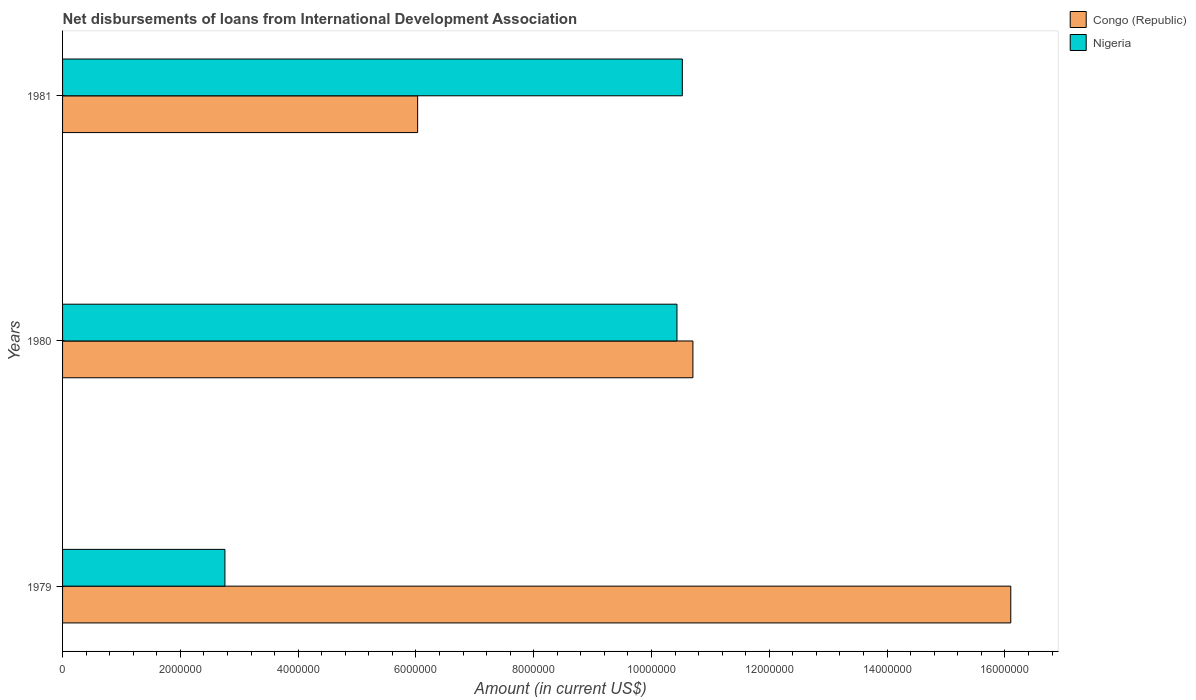How many different coloured bars are there?
Make the answer very short. 2. Are the number of bars per tick equal to the number of legend labels?
Provide a short and direct response. Yes. Are the number of bars on each tick of the Y-axis equal?
Provide a succinct answer. Yes. How many bars are there on the 1st tick from the bottom?
Offer a terse response. 2. What is the label of the 2nd group of bars from the top?
Your answer should be very brief. 1980. What is the amount of loans disbursed in Nigeria in 1981?
Your response must be concise. 1.05e+07. Across all years, what is the maximum amount of loans disbursed in Nigeria?
Make the answer very short. 1.05e+07. Across all years, what is the minimum amount of loans disbursed in Congo (Republic)?
Your response must be concise. 6.03e+06. In which year was the amount of loans disbursed in Nigeria minimum?
Offer a terse response. 1979. What is the total amount of loans disbursed in Congo (Republic) in the graph?
Give a very brief answer. 3.28e+07. What is the difference between the amount of loans disbursed in Nigeria in 1979 and that in 1981?
Provide a short and direct response. -7.77e+06. What is the difference between the amount of loans disbursed in Nigeria in 1981 and the amount of loans disbursed in Congo (Republic) in 1979?
Ensure brevity in your answer.  -5.58e+06. What is the average amount of loans disbursed in Nigeria per year?
Your answer should be compact. 7.90e+06. In the year 1980, what is the difference between the amount of loans disbursed in Nigeria and amount of loans disbursed in Congo (Republic)?
Your answer should be very brief. -2.71e+05. In how many years, is the amount of loans disbursed in Congo (Republic) greater than 10400000 US$?
Provide a succinct answer. 2. What is the ratio of the amount of loans disbursed in Nigeria in 1980 to that in 1981?
Your response must be concise. 0.99. What is the difference between the highest and the second highest amount of loans disbursed in Nigeria?
Make the answer very short. 9.10e+04. What is the difference between the highest and the lowest amount of loans disbursed in Nigeria?
Offer a very short reply. 7.77e+06. In how many years, is the amount of loans disbursed in Congo (Republic) greater than the average amount of loans disbursed in Congo (Republic) taken over all years?
Offer a very short reply. 1. Is the sum of the amount of loans disbursed in Congo (Republic) in 1980 and 1981 greater than the maximum amount of loans disbursed in Nigeria across all years?
Give a very brief answer. Yes. What does the 2nd bar from the top in 1980 represents?
Provide a short and direct response. Congo (Republic). What does the 2nd bar from the bottom in 1979 represents?
Provide a short and direct response. Nigeria. How many years are there in the graph?
Give a very brief answer. 3. Are the values on the major ticks of X-axis written in scientific E-notation?
Your response must be concise. No. Does the graph contain any zero values?
Make the answer very short. No. Does the graph contain grids?
Offer a very short reply. No. Where does the legend appear in the graph?
Offer a terse response. Top right. What is the title of the graph?
Provide a short and direct response. Net disbursements of loans from International Development Association. What is the label or title of the X-axis?
Provide a succinct answer. Amount (in current US$). What is the label or title of the Y-axis?
Provide a short and direct response. Years. What is the Amount (in current US$) in Congo (Republic) in 1979?
Offer a very short reply. 1.61e+07. What is the Amount (in current US$) of Nigeria in 1979?
Offer a very short reply. 2.76e+06. What is the Amount (in current US$) in Congo (Republic) in 1980?
Ensure brevity in your answer.  1.07e+07. What is the Amount (in current US$) in Nigeria in 1980?
Ensure brevity in your answer.  1.04e+07. What is the Amount (in current US$) of Congo (Republic) in 1981?
Provide a succinct answer. 6.03e+06. What is the Amount (in current US$) of Nigeria in 1981?
Your response must be concise. 1.05e+07. Across all years, what is the maximum Amount (in current US$) in Congo (Republic)?
Ensure brevity in your answer.  1.61e+07. Across all years, what is the maximum Amount (in current US$) of Nigeria?
Offer a terse response. 1.05e+07. Across all years, what is the minimum Amount (in current US$) in Congo (Republic)?
Offer a very short reply. 6.03e+06. Across all years, what is the minimum Amount (in current US$) of Nigeria?
Your response must be concise. 2.76e+06. What is the total Amount (in current US$) of Congo (Republic) in the graph?
Provide a short and direct response. 3.28e+07. What is the total Amount (in current US$) of Nigeria in the graph?
Your answer should be very brief. 2.37e+07. What is the difference between the Amount (in current US$) of Congo (Republic) in 1979 and that in 1980?
Ensure brevity in your answer.  5.40e+06. What is the difference between the Amount (in current US$) in Nigeria in 1979 and that in 1980?
Your answer should be compact. -7.68e+06. What is the difference between the Amount (in current US$) in Congo (Republic) in 1979 and that in 1981?
Ensure brevity in your answer.  1.01e+07. What is the difference between the Amount (in current US$) of Nigeria in 1979 and that in 1981?
Your answer should be very brief. -7.77e+06. What is the difference between the Amount (in current US$) in Congo (Republic) in 1980 and that in 1981?
Ensure brevity in your answer.  4.67e+06. What is the difference between the Amount (in current US$) of Nigeria in 1980 and that in 1981?
Keep it short and to the point. -9.10e+04. What is the difference between the Amount (in current US$) of Congo (Republic) in 1979 and the Amount (in current US$) of Nigeria in 1980?
Provide a succinct answer. 5.67e+06. What is the difference between the Amount (in current US$) of Congo (Republic) in 1979 and the Amount (in current US$) of Nigeria in 1981?
Provide a short and direct response. 5.58e+06. What is the average Amount (in current US$) of Congo (Republic) per year?
Give a very brief answer. 1.09e+07. What is the average Amount (in current US$) of Nigeria per year?
Keep it short and to the point. 7.90e+06. In the year 1979, what is the difference between the Amount (in current US$) in Congo (Republic) and Amount (in current US$) in Nigeria?
Give a very brief answer. 1.33e+07. In the year 1980, what is the difference between the Amount (in current US$) in Congo (Republic) and Amount (in current US$) in Nigeria?
Keep it short and to the point. 2.71e+05. In the year 1981, what is the difference between the Amount (in current US$) of Congo (Republic) and Amount (in current US$) of Nigeria?
Provide a short and direct response. -4.49e+06. What is the ratio of the Amount (in current US$) in Congo (Republic) in 1979 to that in 1980?
Offer a very short reply. 1.5. What is the ratio of the Amount (in current US$) in Nigeria in 1979 to that in 1980?
Provide a short and direct response. 0.26. What is the ratio of the Amount (in current US$) of Congo (Republic) in 1979 to that in 1981?
Make the answer very short. 2.67. What is the ratio of the Amount (in current US$) of Nigeria in 1979 to that in 1981?
Ensure brevity in your answer.  0.26. What is the ratio of the Amount (in current US$) in Congo (Republic) in 1980 to that in 1981?
Provide a short and direct response. 1.78. What is the ratio of the Amount (in current US$) in Nigeria in 1980 to that in 1981?
Offer a very short reply. 0.99. What is the difference between the highest and the second highest Amount (in current US$) of Congo (Republic)?
Your answer should be very brief. 5.40e+06. What is the difference between the highest and the second highest Amount (in current US$) in Nigeria?
Ensure brevity in your answer.  9.10e+04. What is the difference between the highest and the lowest Amount (in current US$) of Congo (Republic)?
Provide a succinct answer. 1.01e+07. What is the difference between the highest and the lowest Amount (in current US$) in Nigeria?
Provide a short and direct response. 7.77e+06. 